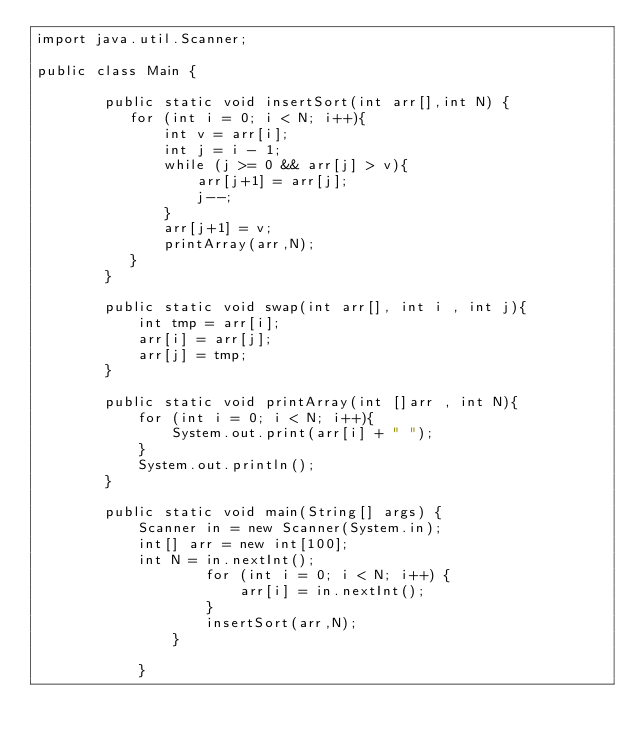Convert code to text. <code><loc_0><loc_0><loc_500><loc_500><_Java_>import java.util.Scanner;

public class Main {

        public static void insertSort(int arr[],int N) {
           for (int i = 0; i < N; i++){
               int v = arr[i];
               int j = i - 1;
               while (j >= 0 && arr[j] > v){
                   arr[j+1] = arr[j];
                   j--;
               }
               arr[j+1] = v;
               printArray(arr,N);
           }
        }

        public static void swap(int arr[], int i , int j){
            int tmp = arr[i];
            arr[i] = arr[j];
            arr[j] = tmp;
        }

        public static void printArray(int []arr , int N){
            for (int i = 0; i < N; i++){
                System.out.print(arr[i] + " ");
            }
            System.out.println();
        }

        public static void main(String[] args) {
            Scanner in = new Scanner(System.in);
            int[] arr = new int[100];
            int N = in.nextInt();
                    for (int i = 0; i < N; i++) {
                        arr[i] = in.nextInt();
                    }
                    insertSort(arr,N);
                }
    
            }
</code> 